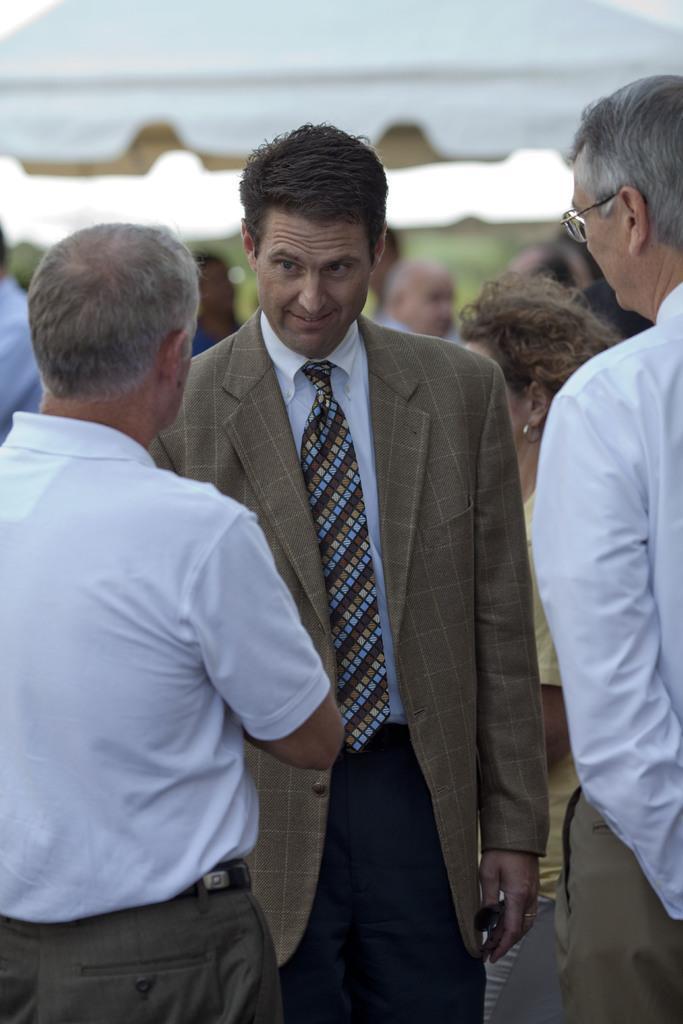Please provide a concise description of this image. This picture shows few people standing and we see a man wore spectacles on his face and another man wore coat and a tie and we see couple of men wore white color shirts. 